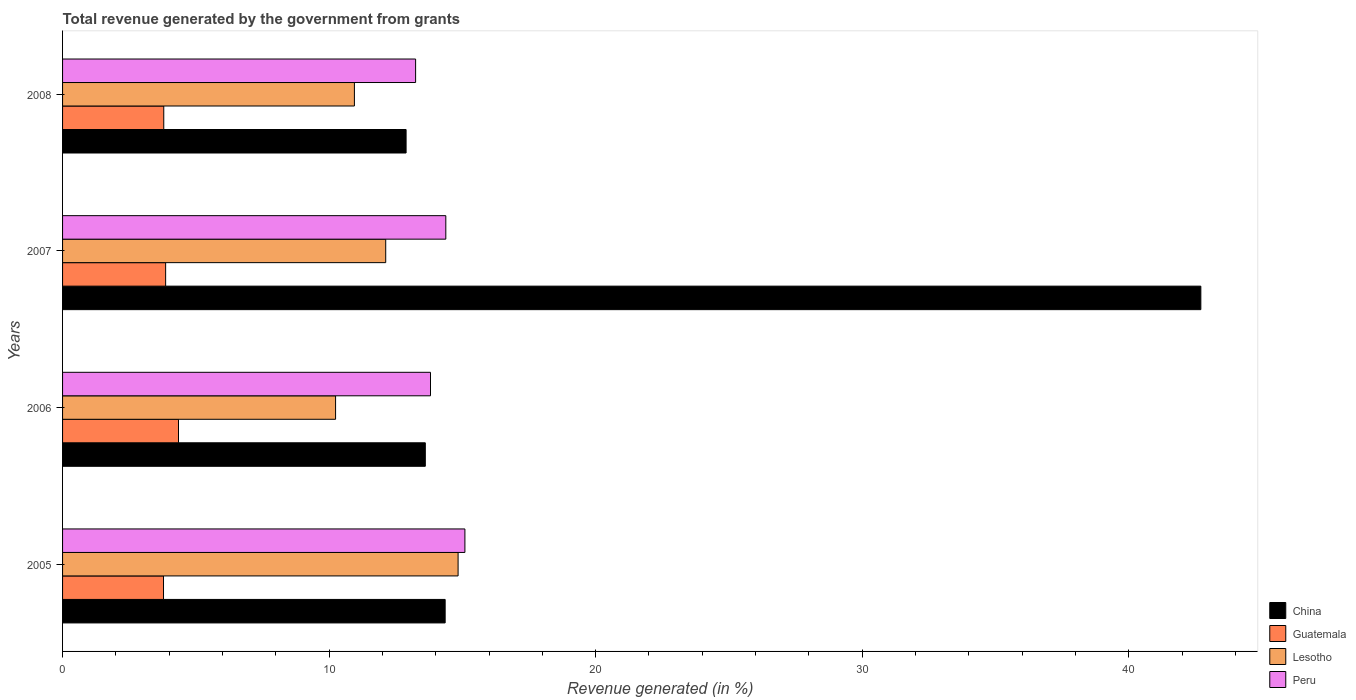How many groups of bars are there?
Your response must be concise. 4. Are the number of bars on each tick of the Y-axis equal?
Provide a short and direct response. Yes. What is the total revenue generated in Peru in 2005?
Provide a short and direct response. 15.09. Across all years, what is the maximum total revenue generated in Peru?
Your response must be concise. 15.09. Across all years, what is the minimum total revenue generated in China?
Offer a terse response. 12.89. In which year was the total revenue generated in Guatemala maximum?
Make the answer very short. 2006. What is the total total revenue generated in Lesotho in the graph?
Your response must be concise. 48.15. What is the difference between the total revenue generated in Guatemala in 2005 and that in 2007?
Your answer should be compact. -0.08. What is the difference between the total revenue generated in Peru in 2006 and the total revenue generated in Lesotho in 2007?
Provide a short and direct response. 1.68. What is the average total revenue generated in Peru per year?
Offer a very short reply. 14.13. In the year 2005, what is the difference between the total revenue generated in Guatemala and total revenue generated in China?
Give a very brief answer. -10.57. In how many years, is the total revenue generated in Peru greater than 42 %?
Provide a succinct answer. 0. What is the ratio of the total revenue generated in China in 2006 to that in 2007?
Ensure brevity in your answer.  0.32. Is the total revenue generated in Peru in 2005 less than that in 2007?
Your response must be concise. No. Is the difference between the total revenue generated in Guatemala in 2006 and 2008 greater than the difference between the total revenue generated in China in 2006 and 2008?
Offer a terse response. No. What is the difference between the highest and the second highest total revenue generated in Guatemala?
Keep it short and to the point. 0.48. What is the difference between the highest and the lowest total revenue generated in Lesotho?
Offer a terse response. 4.6. Is it the case that in every year, the sum of the total revenue generated in Lesotho and total revenue generated in Peru is greater than the sum of total revenue generated in Guatemala and total revenue generated in China?
Your response must be concise. No. What does the 1st bar from the bottom in 2007 represents?
Provide a succinct answer. China. Is it the case that in every year, the sum of the total revenue generated in China and total revenue generated in Guatemala is greater than the total revenue generated in Lesotho?
Your response must be concise. Yes. How many bars are there?
Your answer should be compact. 16. How many years are there in the graph?
Provide a succinct answer. 4. What is the difference between two consecutive major ticks on the X-axis?
Provide a short and direct response. 10. Does the graph contain any zero values?
Provide a succinct answer. No. Where does the legend appear in the graph?
Ensure brevity in your answer.  Bottom right. How are the legend labels stacked?
Offer a very short reply. Vertical. What is the title of the graph?
Keep it short and to the point. Total revenue generated by the government from grants. What is the label or title of the X-axis?
Your answer should be compact. Revenue generated (in %). What is the Revenue generated (in %) in China in 2005?
Your response must be concise. 14.35. What is the Revenue generated (in %) of Guatemala in 2005?
Your response must be concise. 3.79. What is the Revenue generated (in %) of Lesotho in 2005?
Provide a succinct answer. 14.84. What is the Revenue generated (in %) of Peru in 2005?
Offer a terse response. 15.09. What is the Revenue generated (in %) in China in 2006?
Your response must be concise. 13.61. What is the Revenue generated (in %) of Guatemala in 2006?
Make the answer very short. 4.35. What is the Revenue generated (in %) in Lesotho in 2006?
Offer a very short reply. 10.24. What is the Revenue generated (in %) in Peru in 2006?
Your response must be concise. 13.8. What is the Revenue generated (in %) of China in 2007?
Your answer should be compact. 42.7. What is the Revenue generated (in %) in Guatemala in 2007?
Offer a very short reply. 3.87. What is the Revenue generated (in %) in Lesotho in 2007?
Ensure brevity in your answer.  12.12. What is the Revenue generated (in %) of Peru in 2007?
Offer a terse response. 14.38. What is the Revenue generated (in %) of China in 2008?
Offer a very short reply. 12.89. What is the Revenue generated (in %) in Guatemala in 2008?
Offer a very short reply. 3.8. What is the Revenue generated (in %) of Lesotho in 2008?
Your answer should be compact. 10.95. What is the Revenue generated (in %) in Peru in 2008?
Your answer should be compact. 13.24. Across all years, what is the maximum Revenue generated (in %) in China?
Ensure brevity in your answer.  42.7. Across all years, what is the maximum Revenue generated (in %) in Guatemala?
Offer a terse response. 4.35. Across all years, what is the maximum Revenue generated (in %) in Lesotho?
Make the answer very short. 14.84. Across all years, what is the maximum Revenue generated (in %) in Peru?
Offer a terse response. 15.09. Across all years, what is the minimum Revenue generated (in %) in China?
Keep it short and to the point. 12.89. Across all years, what is the minimum Revenue generated (in %) of Guatemala?
Provide a succinct answer. 3.79. Across all years, what is the minimum Revenue generated (in %) of Lesotho?
Your answer should be very brief. 10.24. Across all years, what is the minimum Revenue generated (in %) of Peru?
Your response must be concise. 13.24. What is the total Revenue generated (in %) of China in the graph?
Offer a terse response. 83.55. What is the total Revenue generated (in %) in Guatemala in the graph?
Your answer should be very brief. 15.8. What is the total Revenue generated (in %) of Lesotho in the graph?
Keep it short and to the point. 48.15. What is the total Revenue generated (in %) of Peru in the graph?
Provide a succinct answer. 56.52. What is the difference between the Revenue generated (in %) of China in 2005 and that in 2006?
Offer a very short reply. 0.74. What is the difference between the Revenue generated (in %) of Guatemala in 2005 and that in 2006?
Provide a short and direct response. -0.56. What is the difference between the Revenue generated (in %) in Lesotho in 2005 and that in 2006?
Make the answer very short. 4.6. What is the difference between the Revenue generated (in %) of Peru in 2005 and that in 2006?
Your response must be concise. 1.29. What is the difference between the Revenue generated (in %) in China in 2005 and that in 2007?
Your answer should be very brief. -28.35. What is the difference between the Revenue generated (in %) in Guatemala in 2005 and that in 2007?
Your answer should be compact. -0.08. What is the difference between the Revenue generated (in %) of Lesotho in 2005 and that in 2007?
Provide a short and direct response. 2.72. What is the difference between the Revenue generated (in %) in Peru in 2005 and that in 2007?
Keep it short and to the point. 0.72. What is the difference between the Revenue generated (in %) in China in 2005 and that in 2008?
Provide a succinct answer. 1.47. What is the difference between the Revenue generated (in %) of Guatemala in 2005 and that in 2008?
Provide a short and direct response. -0.01. What is the difference between the Revenue generated (in %) of Lesotho in 2005 and that in 2008?
Your answer should be compact. 3.89. What is the difference between the Revenue generated (in %) of Peru in 2005 and that in 2008?
Keep it short and to the point. 1.85. What is the difference between the Revenue generated (in %) in China in 2006 and that in 2007?
Ensure brevity in your answer.  -29.09. What is the difference between the Revenue generated (in %) of Guatemala in 2006 and that in 2007?
Offer a terse response. 0.48. What is the difference between the Revenue generated (in %) in Lesotho in 2006 and that in 2007?
Make the answer very short. -1.88. What is the difference between the Revenue generated (in %) of Peru in 2006 and that in 2007?
Your answer should be very brief. -0.57. What is the difference between the Revenue generated (in %) of China in 2006 and that in 2008?
Keep it short and to the point. 0.72. What is the difference between the Revenue generated (in %) in Guatemala in 2006 and that in 2008?
Your answer should be compact. 0.55. What is the difference between the Revenue generated (in %) in Lesotho in 2006 and that in 2008?
Ensure brevity in your answer.  -0.71. What is the difference between the Revenue generated (in %) in Peru in 2006 and that in 2008?
Your response must be concise. 0.56. What is the difference between the Revenue generated (in %) of China in 2007 and that in 2008?
Provide a short and direct response. 29.82. What is the difference between the Revenue generated (in %) of Guatemala in 2007 and that in 2008?
Keep it short and to the point. 0.07. What is the difference between the Revenue generated (in %) of Lesotho in 2007 and that in 2008?
Offer a terse response. 1.17. What is the difference between the Revenue generated (in %) of Peru in 2007 and that in 2008?
Offer a terse response. 1.13. What is the difference between the Revenue generated (in %) of China in 2005 and the Revenue generated (in %) of Guatemala in 2006?
Give a very brief answer. 10. What is the difference between the Revenue generated (in %) in China in 2005 and the Revenue generated (in %) in Lesotho in 2006?
Your answer should be very brief. 4.11. What is the difference between the Revenue generated (in %) in China in 2005 and the Revenue generated (in %) in Peru in 2006?
Offer a terse response. 0.55. What is the difference between the Revenue generated (in %) in Guatemala in 2005 and the Revenue generated (in %) in Lesotho in 2006?
Ensure brevity in your answer.  -6.45. What is the difference between the Revenue generated (in %) of Guatemala in 2005 and the Revenue generated (in %) of Peru in 2006?
Ensure brevity in your answer.  -10.02. What is the difference between the Revenue generated (in %) of Lesotho in 2005 and the Revenue generated (in %) of Peru in 2006?
Give a very brief answer. 1.04. What is the difference between the Revenue generated (in %) in China in 2005 and the Revenue generated (in %) in Guatemala in 2007?
Your answer should be compact. 10.49. What is the difference between the Revenue generated (in %) in China in 2005 and the Revenue generated (in %) in Lesotho in 2007?
Your answer should be compact. 2.23. What is the difference between the Revenue generated (in %) of China in 2005 and the Revenue generated (in %) of Peru in 2007?
Your answer should be compact. -0.02. What is the difference between the Revenue generated (in %) of Guatemala in 2005 and the Revenue generated (in %) of Lesotho in 2007?
Make the answer very short. -8.34. What is the difference between the Revenue generated (in %) of Guatemala in 2005 and the Revenue generated (in %) of Peru in 2007?
Ensure brevity in your answer.  -10.59. What is the difference between the Revenue generated (in %) in Lesotho in 2005 and the Revenue generated (in %) in Peru in 2007?
Ensure brevity in your answer.  0.46. What is the difference between the Revenue generated (in %) in China in 2005 and the Revenue generated (in %) in Guatemala in 2008?
Ensure brevity in your answer.  10.56. What is the difference between the Revenue generated (in %) in China in 2005 and the Revenue generated (in %) in Lesotho in 2008?
Your response must be concise. 3.4. What is the difference between the Revenue generated (in %) in China in 2005 and the Revenue generated (in %) in Peru in 2008?
Keep it short and to the point. 1.11. What is the difference between the Revenue generated (in %) of Guatemala in 2005 and the Revenue generated (in %) of Lesotho in 2008?
Offer a very short reply. -7.16. What is the difference between the Revenue generated (in %) in Guatemala in 2005 and the Revenue generated (in %) in Peru in 2008?
Offer a very short reply. -9.46. What is the difference between the Revenue generated (in %) in Lesotho in 2005 and the Revenue generated (in %) in Peru in 2008?
Give a very brief answer. 1.59. What is the difference between the Revenue generated (in %) of China in 2006 and the Revenue generated (in %) of Guatemala in 2007?
Offer a very short reply. 9.74. What is the difference between the Revenue generated (in %) of China in 2006 and the Revenue generated (in %) of Lesotho in 2007?
Your response must be concise. 1.49. What is the difference between the Revenue generated (in %) of China in 2006 and the Revenue generated (in %) of Peru in 2007?
Provide a short and direct response. -0.77. What is the difference between the Revenue generated (in %) of Guatemala in 2006 and the Revenue generated (in %) of Lesotho in 2007?
Make the answer very short. -7.77. What is the difference between the Revenue generated (in %) of Guatemala in 2006 and the Revenue generated (in %) of Peru in 2007?
Offer a terse response. -10.03. What is the difference between the Revenue generated (in %) of Lesotho in 2006 and the Revenue generated (in %) of Peru in 2007?
Your response must be concise. -4.14. What is the difference between the Revenue generated (in %) of China in 2006 and the Revenue generated (in %) of Guatemala in 2008?
Your answer should be compact. 9.81. What is the difference between the Revenue generated (in %) of China in 2006 and the Revenue generated (in %) of Lesotho in 2008?
Provide a short and direct response. 2.66. What is the difference between the Revenue generated (in %) of China in 2006 and the Revenue generated (in %) of Peru in 2008?
Offer a very short reply. 0.36. What is the difference between the Revenue generated (in %) in Guatemala in 2006 and the Revenue generated (in %) in Lesotho in 2008?
Offer a terse response. -6.6. What is the difference between the Revenue generated (in %) in Guatemala in 2006 and the Revenue generated (in %) in Peru in 2008?
Offer a very short reply. -8.9. What is the difference between the Revenue generated (in %) in Lesotho in 2006 and the Revenue generated (in %) in Peru in 2008?
Your answer should be compact. -3. What is the difference between the Revenue generated (in %) of China in 2007 and the Revenue generated (in %) of Guatemala in 2008?
Your answer should be compact. 38.91. What is the difference between the Revenue generated (in %) of China in 2007 and the Revenue generated (in %) of Lesotho in 2008?
Provide a succinct answer. 31.75. What is the difference between the Revenue generated (in %) of China in 2007 and the Revenue generated (in %) of Peru in 2008?
Your answer should be very brief. 29.46. What is the difference between the Revenue generated (in %) in Guatemala in 2007 and the Revenue generated (in %) in Lesotho in 2008?
Give a very brief answer. -7.08. What is the difference between the Revenue generated (in %) in Guatemala in 2007 and the Revenue generated (in %) in Peru in 2008?
Offer a very short reply. -9.38. What is the difference between the Revenue generated (in %) in Lesotho in 2007 and the Revenue generated (in %) in Peru in 2008?
Keep it short and to the point. -1.12. What is the average Revenue generated (in %) of China per year?
Give a very brief answer. 20.89. What is the average Revenue generated (in %) of Guatemala per year?
Keep it short and to the point. 3.95. What is the average Revenue generated (in %) in Lesotho per year?
Offer a very short reply. 12.04. What is the average Revenue generated (in %) in Peru per year?
Your response must be concise. 14.13. In the year 2005, what is the difference between the Revenue generated (in %) of China and Revenue generated (in %) of Guatemala?
Your answer should be compact. 10.57. In the year 2005, what is the difference between the Revenue generated (in %) of China and Revenue generated (in %) of Lesotho?
Make the answer very short. -0.49. In the year 2005, what is the difference between the Revenue generated (in %) of China and Revenue generated (in %) of Peru?
Make the answer very short. -0.74. In the year 2005, what is the difference between the Revenue generated (in %) of Guatemala and Revenue generated (in %) of Lesotho?
Provide a short and direct response. -11.05. In the year 2005, what is the difference between the Revenue generated (in %) in Guatemala and Revenue generated (in %) in Peru?
Make the answer very short. -11.31. In the year 2005, what is the difference between the Revenue generated (in %) of Lesotho and Revenue generated (in %) of Peru?
Provide a short and direct response. -0.26. In the year 2006, what is the difference between the Revenue generated (in %) in China and Revenue generated (in %) in Guatemala?
Provide a short and direct response. 9.26. In the year 2006, what is the difference between the Revenue generated (in %) of China and Revenue generated (in %) of Lesotho?
Make the answer very short. 3.37. In the year 2006, what is the difference between the Revenue generated (in %) of China and Revenue generated (in %) of Peru?
Keep it short and to the point. -0.19. In the year 2006, what is the difference between the Revenue generated (in %) in Guatemala and Revenue generated (in %) in Lesotho?
Provide a succinct answer. -5.89. In the year 2006, what is the difference between the Revenue generated (in %) of Guatemala and Revenue generated (in %) of Peru?
Ensure brevity in your answer.  -9.45. In the year 2006, what is the difference between the Revenue generated (in %) of Lesotho and Revenue generated (in %) of Peru?
Your answer should be very brief. -3.56. In the year 2007, what is the difference between the Revenue generated (in %) of China and Revenue generated (in %) of Guatemala?
Your response must be concise. 38.84. In the year 2007, what is the difference between the Revenue generated (in %) of China and Revenue generated (in %) of Lesotho?
Offer a terse response. 30.58. In the year 2007, what is the difference between the Revenue generated (in %) of China and Revenue generated (in %) of Peru?
Provide a short and direct response. 28.33. In the year 2007, what is the difference between the Revenue generated (in %) in Guatemala and Revenue generated (in %) in Lesotho?
Give a very brief answer. -8.26. In the year 2007, what is the difference between the Revenue generated (in %) of Guatemala and Revenue generated (in %) of Peru?
Offer a very short reply. -10.51. In the year 2007, what is the difference between the Revenue generated (in %) in Lesotho and Revenue generated (in %) in Peru?
Provide a short and direct response. -2.25. In the year 2008, what is the difference between the Revenue generated (in %) of China and Revenue generated (in %) of Guatemala?
Provide a short and direct response. 9.09. In the year 2008, what is the difference between the Revenue generated (in %) of China and Revenue generated (in %) of Lesotho?
Your answer should be compact. 1.94. In the year 2008, what is the difference between the Revenue generated (in %) in China and Revenue generated (in %) in Peru?
Offer a terse response. -0.36. In the year 2008, what is the difference between the Revenue generated (in %) in Guatemala and Revenue generated (in %) in Lesotho?
Your response must be concise. -7.15. In the year 2008, what is the difference between the Revenue generated (in %) in Guatemala and Revenue generated (in %) in Peru?
Give a very brief answer. -9.45. In the year 2008, what is the difference between the Revenue generated (in %) of Lesotho and Revenue generated (in %) of Peru?
Keep it short and to the point. -2.3. What is the ratio of the Revenue generated (in %) in China in 2005 to that in 2006?
Provide a succinct answer. 1.05. What is the ratio of the Revenue generated (in %) of Guatemala in 2005 to that in 2006?
Your answer should be very brief. 0.87. What is the ratio of the Revenue generated (in %) of Lesotho in 2005 to that in 2006?
Provide a short and direct response. 1.45. What is the ratio of the Revenue generated (in %) of Peru in 2005 to that in 2006?
Ensure brevity in your answer.  1.09. What is the ratio of the Revenue generated (in %) of China in 2005 to that in 2007?
Your response must be concise. 0.34. What is the ratio of the Revenue generated (in %) in Guatemala in 2005 to that in 2007?
Your response must be concise. 0.98. What is the ratio of the Revenue generated (in %) in Lesotho in 2005 to that in 2007?
Provide a short and direct response. 1.22. What is the ratio of the Revenue generated (in %) in Peru in 2005 to that in 2007?
Give a very brief answer. 1.05. What is the ratio of the Revenue generated (in %) of China in 2005 to that in 2008?
Your answer should be very brief. 1.11. What is the ratio of the Revenue generated (in %) in Guatemala in 2005 to that in 2008?
Provide a succinct answer. 1. What is the ratio of the Revenue generated (in %) in Lesotho in 2005 to that in 2008?
Make the answer very short. 1.36. What is the ratio of the Revenue generated (in %) of Peru in 2005 to that in 2008?
Provide a short and direct response. 1.14. What is the ratio of the Revenue generated (in %) of China in 2006 to that in 2007?
Your answer should be compact. 0.32. What is the ratio of the Revenue generated (in %) of Guatemala in 2006 to that in 2007?
Your answer should be compact. 1.12. What is the ratio of the Revenue generated (in %) in Lesotho in 2006 to that in 2007?
Provide a short and direct response. 0.84. What is the ratio of the Revenue generated (in %) in China in 2006 to that in 2008?
Offer a terse response. 1.06. What is the ratio of the Revenue generated (in %) in Guatemala in 2006 to that in 2008?
Ensure brevity in your answer.  1.15. What is the ratio of the Revenue generated (in %) in Lesotho in 2006 to that in 2008?
Your response must be concise. 0.94. What is the ratio of the Revenue generated (in %) in Peru in 2006 to that in 2008?
Offer a very short reply. 1.04. What is the ratio of the Revenue generated (in %) of China in 2007 to that in 2008?
Your answer should be very brief. 3.31. What is the ratio of the Revenue generated (in %) in Guatemala in 2007 to that in 2008?
Make the answer very short. 1.02. What is the ratio of the Revenue generated (in %) in Lesotho in 2007 to that in 2008?
Ensure brevity in your answer.  1.11. What is the ratio of the Revenue generated (in %) in Peru in 2007 to that in 2008?
Your response must be concise. 1.09. What is the difference between the highest and the second highest Revenue generated (in %) in China?
Your answer should be very brief. 28.35. What is the difference between the highest and the second highest Revenue generated (in %) in Guatemala?
Keep it short and to the point. 0.48. What is the difference between the highest and the second highest Revenue generated (in %) in Lesotho?
Make the answer very short. 2.72. What is the difference between the highest and the second highest Revenue generated (in %) in Peru?
Provide a succinct answer. 0.72. What is the difference between the highest and the lowest Revenue generated (in %) of China?
Your response must be concise. 29.82. What is the difference between the highest and the lowest Revenue generated (in %) in Guatemala?
Make the answer very short. 0.56. What is the difference between the highest and the lowest Revenue generated (in %) in Lesotho?
Your answer should be compact. 4.6. What is the difference between the highest and the lowest Revenue generated (in %) of Peru?
Your answer should be very brief. 1.85. 